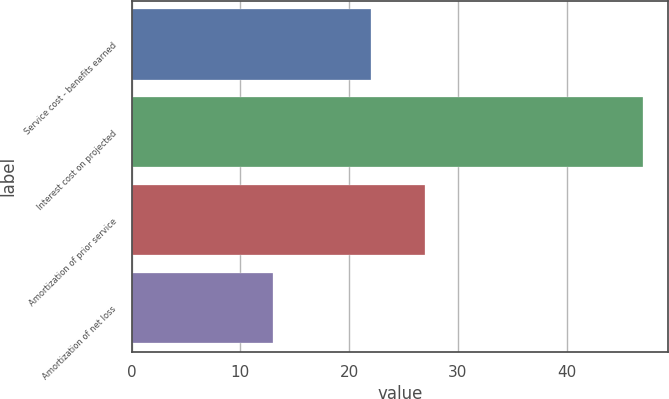Convert chart to OTSL. <chart><loc_0><loc_0><loc_500><loc_500><bar_chart><fcel>Service cost - benefits earned<fcel>Interest cost on projected<fcel>Amortization of prior service<fcel>Amortization of net loss<nl><fcel>22<fcel>47<fcel>27<fcel>13<nl></chart> 